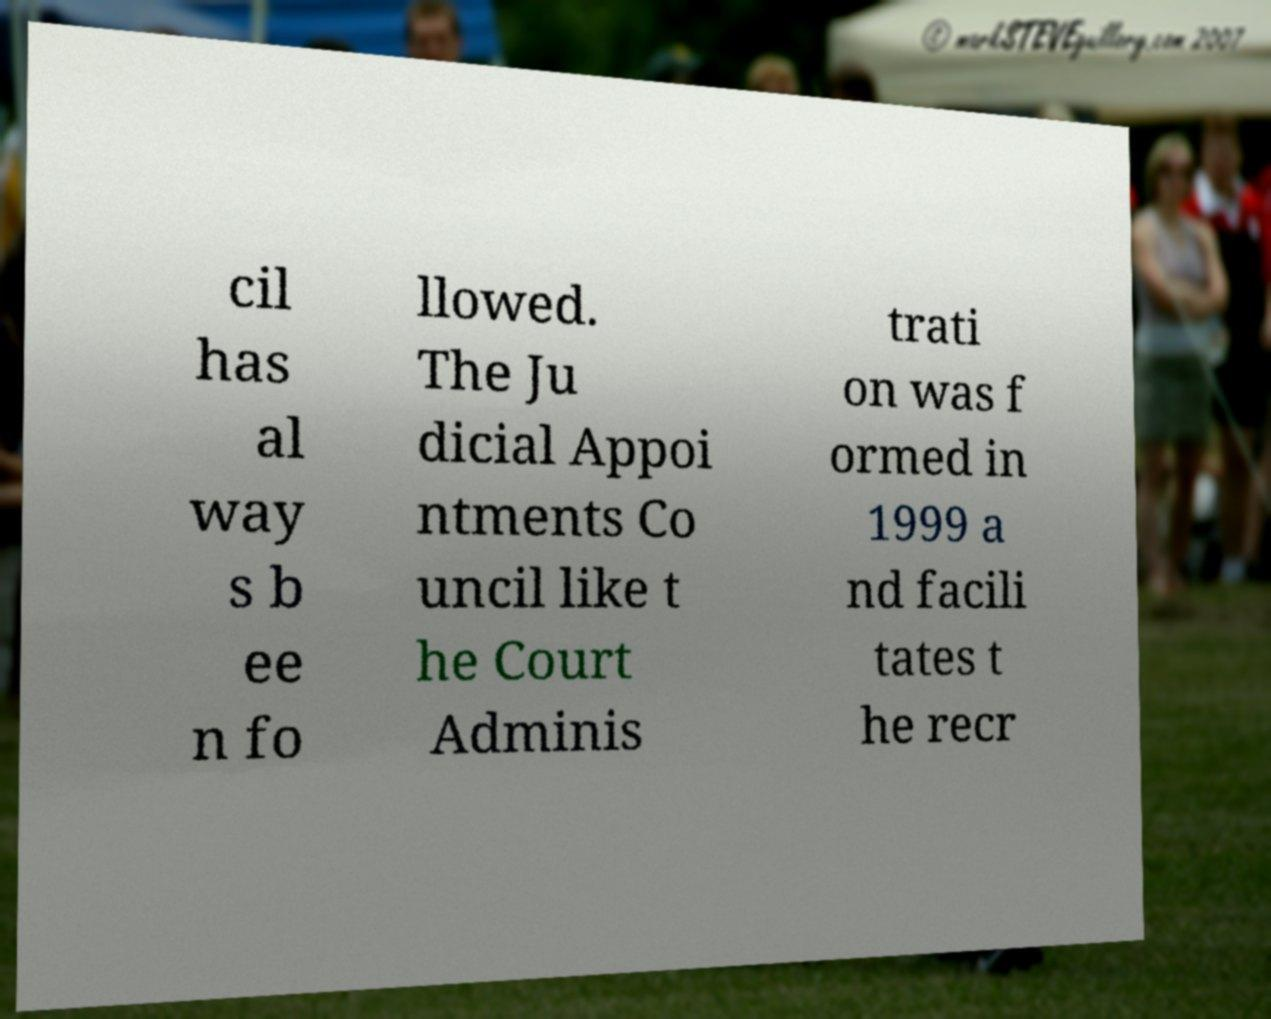Can you read and provide the text displayed in the image?This photo seems to have some interesting text. Can you extract and type it out for me? cil has al way s b ee n fo llowed. The Ju dicial Appoi ntments Co uncil like t he Court Adminis trati on was f ormed in 1999 a nd facili tates t he recr 